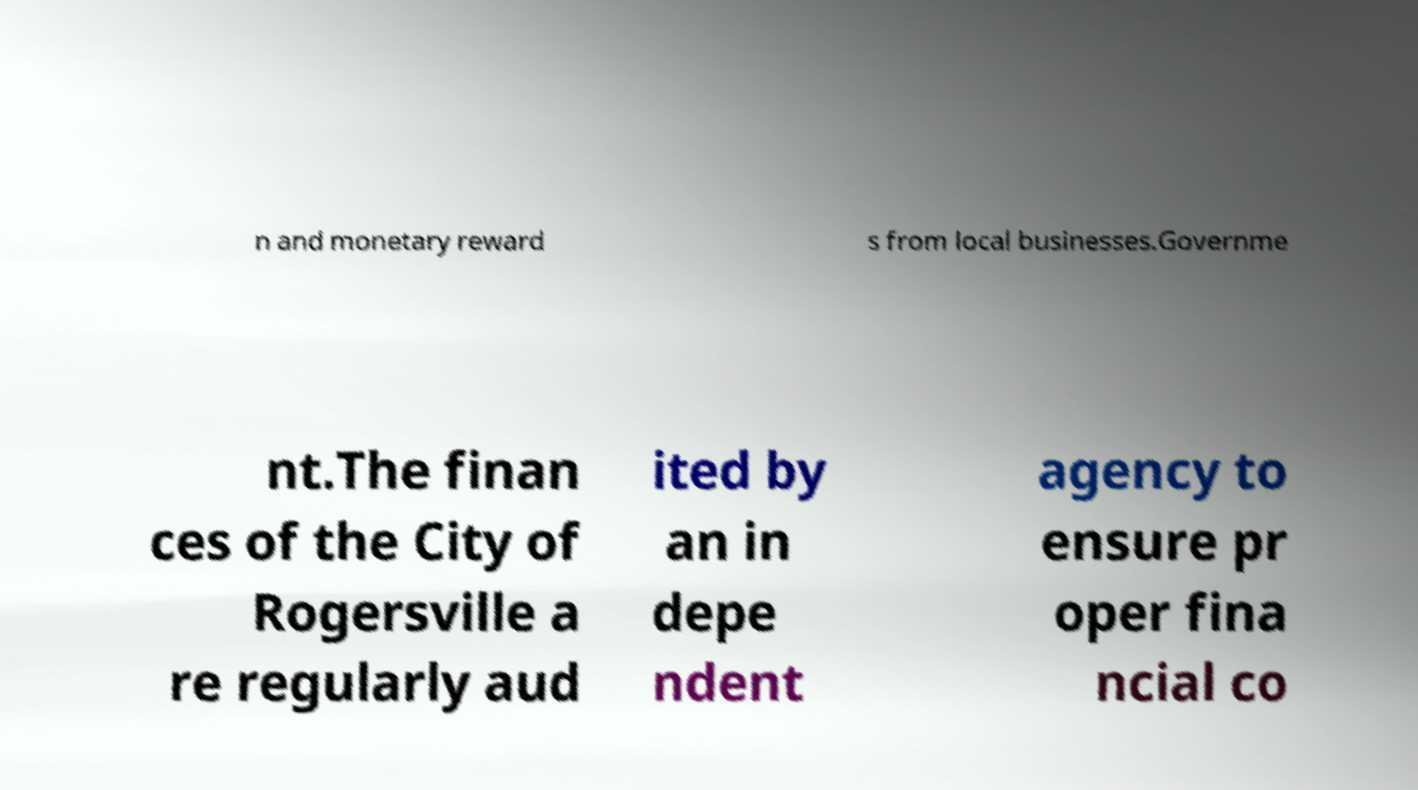Could you extract and type out the text from this image? n and monetary reward s from local businesses.Governme nt.The finan ces of the City of Rogersville a re regularly aud ited by an in depe ndent agency to ensure pr oper fina ncial co 